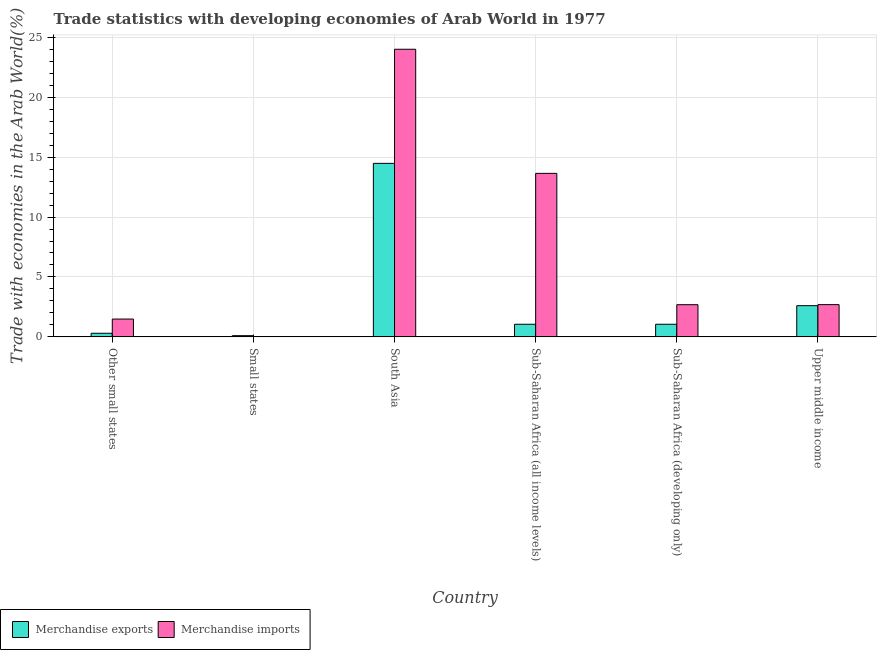How many different coloured bars are there?
Your answer should be compact. 2. Are the number of bars on each tick of the X-axis equal?
Provide a succinct answer. Yes. How many bars are there on the 1st tick from the left?
Your response must be concise. 2. How many bars are there on the 4th tick from the right?
Keep it short and to the point. 2. What is the label of the 1st group of bars from the left?
Keep it short and to the point. Other small states. In how many cases, is the number of bars for a given country not equal to the number of legend labels?
Make the answer very short. 0. What is the merchandise imports in Sub-Saharan Africa (all income levels)?
Offer a terse response. 13.64. Across all countries, what is the maximum merchandise imports?
Offer a terse response. 24. Across all countries, what is the minimum merchandise exports?
Provide a short and direct response. 0.1. In which country was the merchandise exports maximum?
Provide a succinct answer. South Asia. In which country was the merchandise exports minimum?
Offer a very short reply. Small states. What is the total merchandise imports in the graph?
Your answer should be compact. 44.54. What is the difference between the merchandise exports in Sub-Saharan Africa (developing only) and that in Upper middle income?
Offer a very short reply. -1.55. What is the difference between the merchandise imports in Sub-Saharan Africa (developing only) and the merchandise exports in South Asia?
Provide a short and direct response. -11.79. What is the average merchandise imports per country?
Offer a very short reply. 7.42. What is the difference between the merchandise imports and merchandise exports in Sub-Saharan Africa (all income levels)?
Your answer should be compact. 12.59. What is the ratio of the merchandise imports in South Asia to that in Sub-Saharan Africa (all income levels)?
Offer a very short reply. 1.76. Is the merchandise exports in Other small states less than that in Upper middle income?
Your response must be concise. Yes. What is the difference between the highest and the second highest merchandise exports?
Give a very brief answer. 11.88. What is the difference between the highest and the lowest merchandise exports?
Ensure brevity in your answer.  14.38. Is the sum of the merchandise exports in Small states and Sub-Saharan Africa (developing only) greater than the maximum merchandise imports across all countries?
Your answer should be compact. No. What does the 2nd bar from the left in South Asia represents?
Ensure brevity in your answer.  Merchandise imports. How many bars are there?
Offer a very short reply. 12. Are all the bars in the graph horizontal?
Your answer should be very brief. No. How many countries are there in the graph?
Your answer should be compact. 6. Does the graph contain grids?
Your answer should be very brief. Yes. Where does the legend appear in the graph?
Provide a succinct answer. Bottom left. How are the legend labels stacked?
Make the answer very short. Horizontal. What is the title of the graph?
Keep it short and to the point. Trade statistics with developing economies of Arab World in 1977. What is the label or title of the Y-axis?
Ensure brevity in your answer.  Trade with economies in the Arab World(%). What is the Trade with economies in the Arab World(%) in Merchandise exports in Other small states?
Your response must be concise. 0.3. What is the Trade with economies in the Arab World(%) in Merchandise imports in Other small states?
Your answer should be compact. 1.49. What is the Trade with economies in the Arab World(%) in Merchandise exports in Small states?
Offer a very short reply. 0.1. What is the Trade with economies in the Arab World(%) of Merchandise imports in Small states?
Provide a succinct answer. 0.03. What is the Trade with economies in the Arab World(%) of Merchandise exports in South Asia?
Offer a very short reply. 14.48. What is the Trade with economies in the Arab World(%) in Merchandise imports in South Asia?
Make the answer very short. 24. What is the Trade with economies in the Arab World(%) in Merchandise exports in Sub-Saharan Africa (all income levels)?
Provide a short and direct response. 1.05. What is the Trade with economies in the Arab World(%) of Merchandise imports in Sub-Saharan Africa (all income levels)?
Your answer should be very brief. 13.64. What is the Trade with economies in the Arab World(%) of Merchandise exports in Sub-Saharan Africa (developing only)?
Provide a short and direct response. 1.05. What is the Trade with economies in the Arab World(%) in Merchandise imports in Sub-Saharan Africa (developing only)?
Your answer should be very brief. 2.68. What is the Trade with economies in the Arab World(%) of Merchandise exports in Upper middle income?
Your answer should be compact. 2.6. What is the Trade with economies in the Arab World(%) of Merchandise imports in Upper middle income?
Your answer should be very brief. 2.69. Across all countries, what is the maximum Trade with economies in the Arab World(%) in Merchandise exports?
Offer a very short reply. 14.48. Across all countries, what is the maximum Trade with economies in the Arab World(%) of Merchandise imports?
Make the answer very short. 24. Across all countries, what is the minimum Trade with economies in the Arab World(%) in Merchandise exports?
Your response must be concise. 0.1. Across all countries, what is the minimum Trade with economies in the Arab World(%) of Merchandise imports?
Your response must be concise. 0.03. What is the total Trade with economies in the Arab World(%) of Merchandise exports in the graph?
Your answer should be very brief. 19.59. What is the total Trade with economies in the Arab World(%) in Merchandise imports in the graph?
Ensure brevity in your answer.  44.54. What is the difference between the Trade with economies in the Arab World(%) in Merchandise exports in Other small states and that in Small states?
Provide a succinct answer. 0.2. What is the difference between the Trade with economies in the Arab World(%) in Merchandise imports in Other small states and that in Small states?
Offer a terse response. 1.46. What is the difference between the Trade with economies in the Arab World(%) in Merchandise exports in Other small states and that in South Asia?
Offer a very short reply. -14.18. What is the difference between the Trade with economies in the Arab World(%) of Merchandise imports in Other small states and that in South Asia?
Offer a very short reply. -22.51. What is the difference between the Trade with economies in the Arab World(%) in Merchandise exports in Other small states and that in Sub-Saharan Africa (all income levels)?
Provide a short and direct response. -0.75. What is the difference between the Trade with economies in the Arab World(%) in Merchandise imports in Other small states and that in Sub-Saharan Africa (all income levels)?
Give a very brief answer. -12.16. What is the difference between the Trade with economies in the Arab World(%) in Merchandise exports in Other small states and that in Sub-Saharan Africa (developing only)?
Your response must be concise. -0.75. What is the difference between the Trade with economies in the Arab World(%) of Merchandise imports in Other small states and that in Sub-Saharan Africa (developing only)?
Your answer should be very brief. -1.2. What is the difference between the Trade with economies in the Arab World(%) of Merchandise exports in Other small states and that in Upper middle income?
Make the answer very short. -2.3. What is the difference between the Trade with economies in the Arab World(%) in Merchandise imports in Other small states and that in Upper middle income?
Offer a very short reply. -1.2. What is the difference between the Trade with economies in the Arab World(%) of Merchandise exports in Small states and that in South Asia?
Keep it short and to the point. -14.38. What is the difference between the Trade with economies in the Arab World(%) in Merchandise imports in Small states and that in South Asia?
Ensure brevity in your answer.  -23.97. What is the difference between the Trade with economies in the Arab World(%) in Merchandise exports in Small states and that in Sub-Saharan Africa (all income levels)?
Provide a short and direct response. -0.95. What is the difference between the Trade with economies in the Arab World(%) in Merchandise imports in Small states and that in Sub-Saharan Africa (all income levels)?
Make the answer very short. -13.61. What is the difference between the Trade with economies in the Arab World(%) in Merchandise exports in Small states and that in Sub-Saharan Africa (developing only)?
Offer a terse response. -0.95. What is the difference between the Trade with economies in the Arab World(%) of Merchandise imports in Small states and that in Sub-Saharan Africa (developing only)?
Offer a terse response. -2.65. What is the difference between the Trade with economies in the Arab World(%) of Merchandise exports in Small states and that in Upper middle income?
Your response must be concise. -2.5. What is the difference between the Trade with economies in the Arab World(%) in Merchandise imports in Small states and that in Upper middle income?
Provide a succinct answer. -2.66. What is the difference between the Trade with economies in the Arab World(%) of Merchandise exports in South Asia and that in Sub-Saharan Africa (all income levels)?
Your answer should be compact. 13.43. What is the difference between the Trade with economies in the Arab World(%) of Merchandise imports in South Asia and that in Sub-Saharan Africa (all income levels)?
Offer a very short reply. 10.36. What is the difference between the Trade with economies in the Arab World(%) in Merchandise exports in South Asia and that in Sub-Saharan Africa (developing only)?
Provide a short and direct response. 13.43. What is the difference between the Trade with economies in the Arab World(%) of Merchandise imports in South Asia and that in Sub-Saharan Africa (developing only)?
Offer a terse response. 21.32. What is the difference between the Trade with economies in the Arab World(%) of Merchandise exports in South Asia and that in Upper middle income?
Offer a terse response. 11.88. What is the difference between the Trade with economies in the Arab World(%) in Merchandise imports in South Asia and that in Upper middle income?
Give a very brief answer. 21.31. What is the difference between the Trade with economies in the Arab World(%) in Merchandise imports in Sub-Saharan Africa (all income levels) and that in Sub-Saharan Africa (developing only)?
Your response must be concise. 10.96. What is the difference between the Trade with economies in the Arab World(%) of Merchandise exports in Sub-Saharan Africa (all income levels) and that in Upper middle income?
Keep it short and to the point. -1.55. What is the difference between the Trade with economies in the Arab World(%) of Merchandise imports in Sub-Saharan Africa (all income levels) and that in Upper middle income?
Keep it short and to the point. 10.95. What is the difference between the Trade with economies in the Arab World(%) in Merchandise exports in Sub-Saharan Africa (developing only) and that in Upper middle income?
Offer a very short reply. -1.55. What is the difference between the Trade with economies in the Arab World(%) in Merchandise imports in Sub-Saharan Africa (developing only) and that in Upper middle income?
Provide a short and direct response. -0.01. What is the difference between the Trade with economies in the Arab World(%) in Merchandise exports in Other small states and the Trade with economies in the Arab World(%) in Merchandise imports in Small states?
Provide a succinct answer. 0.27. What is the difference between the Trade with economies in the Arab World(%) in Merchandise exports in Other small states and the Trade with economies in the Arab World(%) in Merchandise imports in South Asia?
Your response must be concise. -23.7. What is the difference between the Trade with economies in the Arab World(%) in Merchandise exports in Other small states and the Trade with economies in the Arab World(%) in Merchandise imports in Sub-Saharan Africa (all income levels)?
Provide a succinct answer. -13.34. What is the difference between the Trade with economies in the Arab World(%) in Merchandise exports in Other small states and the Trade with economies in the Arab World(%) in Merchandise imports in Sub-Saharan Africa (developing only)?
Your response must be concise. -2.38. What is the difference between the Trade with economies in the Arab World(%) of Merchandise exports in Other small states and the Trade with economies in the Arab World(%) of Merchandise imports in Upper middle income?
Keep it short and to the point. -2.39. What is the difference between the Trade with economies in the Arab World(%) in Merchandise exports in Small states and the Trade with economies in the Arab World(%) in Merchandise imports in South Asia?
Your response must be concise. -23.9. What is the difference between the Trade with economies in the Arab World(%) in Merchandise exports in Small states and the Trade with economies in the Arab World(%) in Merchandise imports in Sub-Saharan Africa (all income levels)?
Offer a very short reply. -13.54. What is the difference between the Trade with economies in the Arab World(%) of Merchandise exports in Small states and the Trade with economies in the Arab World(%) of Merchandise imports in Sub-Saharan Africa (developing only)?
Your answer should be very brief. -2.58. What is the difference between the Trade with economies in the Arab World(%) of Merchandise exports in Small states and the Trade with economies in the Arab World(%) of Merchandise imports in Upper middle income?
Make the answer very short. -2.59. What is the difference between the Trade with economies in the Arab World(%) in Merchandise exports in South Asia and the Trade with economies in the Arab World(%) in Merchandise imports in Sub-Saharan Africa (all income levels)?
Keep it short and to the point. 0.84. What is the difference between the Trade with economies in the Arab World(%) in Merchandise exports in South Asia and the Trade with economies in the Arab World(%) in Merchandise imports in Sub-Saharan Africa (developing only)?
Give a very brief answer. 11.79. What is the difference between the Trade with economies in the Arab World(%) of Merchandise exports in South Asia and the Trade with economies in the Arab World(%) of Merchandise imports in Upper middle income?
Your answer should be compact. 11.79. What is the difference between the Trade with economies in the Arab World(%) in Merchandise exports in Sub-Saharan Africa (all income levels) and the Trade with economies in the Arab World(%) in Merchandise imports in Sub-Saharan Africa (developing only)?
Your response must be concise. -1.63. What is the difference between the Trade with economies in the Arab World(%) of Merchandise exports in Sub-Saharan Africa (all income levels) and the Trade with economies in the Arab World(%) of Merchandise imports in Upper middle income?
Give a very brief answer. -1.64. What is the difference between the Trade with economies in the Arab World(%) in Merchandise exports in Sub-Saharan Africa (developing only) and the Trade with economies in the Arab World(%) in Merchandise imports in Upper middle income?
Give a very brief answer. -1.64. What is the average Trade with economies in the Arab World(%) of Merchandise exports per country?
Your response must be concise. 3.26. What is the average Trade with economies in the Arab World(%) in Merchandise imports per country?
Make the answer very short. 7.42. What is the difference between the Trade with economies in the Arab World(%) of Merchandise exports and Trade with economies in the Arab World(%) of Merchandise imports in Other small states?
Your answer should be compact. -1.18. What is the difference between the Trade with economies in the Arab World(%) in Merchandise exports and Trade with economies in the Arab World(%) in Merchandise imports in Small states?
Offer a very short reply. 0.07. What is the difference between the Trade with economies in the Arab World(%) in Merchandise exports and Trade with economies in the Arab World(%) in Merchandise imports in South Asia?
Your answer should be compact. -9.52. What is the difference between the Trade with economies in the Arab World(%) in Merchandise exports and Trade with economies in the Arab World(%) in Merchandise imports in Sub-Saharan Africa (all income levels)?
Ensure brevity in your answer.  -12.59. What is the difference between the Trade with economies in the Arab World(%) of Merchandise exports and Trade with economies in the Arab World(%) of Merchandise imports in Sub-Saharan Africa (developing only)?
Give a very brief answer. -1.63. What is the difference between the Trade with economies in the Arab World(%) of Merchandise exports and Trade with economies in the Arab World(%) of Merchandise imports in Upper middle income?
Offer a terse response. -0.09. What is the ratio of the Trade with economies in the Arab World(%) in Merchandise exports in Other small states to that in Small states?
Offer a terse response. 2.99. What is the ratio of the Trade with economies in the Arab World(%) of Merchandise imports in Other small states to that in Small states?
Offer a terse response. 48.01. What is the ratio of the Trade with economies in the Arab World(%) in Merchandise exports in Other small states to that in South Asia?
Your answer should be very brief. 0.02. What is the ratio of the Trade with economies in the Arab World(%) in Merchandise imports in Other small states to that in South Asia?
Your answer should be very brief. 0.06. What is the ratio of the Trade with economies in the Arab World(%) in Merchandise exports in Other small states to that in Sub-Saharan Africa (all income levels)?
Make the answer very short. 0.29. What is the ratio of the Trade with economies in the Arab World(%) of Merchandise imports in Other small states to that in Sub-Saharan Africa (all income levels)?
Provide a short and direct response. 0.11. What is the ratio of the Trade with economies in the Arab World(%) of Merchandise exports in Other small states to that in Sub-Saharan Africa (developing only)?
Provide a short and direct response. 0.29. What is the ratio of the Trade with economies in the Arab World(%) in Merchandise imports in Other small states to that in Sub-Saharan Africa (developing only)?
Provide a short and direct response. 0.55. What is the ratio of the Trade with economies in the Arab World(%) of Merchandise exports in Other small states to that in Upper middle income?
Keep it short and to the point. 0.12. What is the ratio of the Trade with economies in the Arab World(%) of Merchandise imports in Other small states to that in Upper middle income?
Your answer should be very brief. 0.55. What is the ratio of the Trade with economies in the Arab World(%) of Merchandise exports in Small states to that in South Asia?
Your response must be concise. 0.01. What is the ratio of the Trade with economies in the Arab World(%) of Merchandise imports in Small states to that in South Asia?
Offer a terse response. 0. What is the ratio of the Trade with economies in the Arab World(%) of Merchandise exports in Small states to that in Sub-Saharan Africa (all income levels)?
Make the answer very short. 0.1. What is the ratio of the Trade with economies in the Arab World(%) of Merchandise imports in Small states to that in Sub-Saharan Africa (all income levels)?
Offer a terse response. 0. What is the ratio of the Trade with economies in the Arab World(%) in Merchandise exports in Small states to that in Sub-Saharan Africa (developing only)?
Provide a succinct answer. 0.1. What is the ratio of the Trade with economies in the Arab World(%) of Merchandise imports in Small states to that in Sub-Saharan Africa (developing only)?
Offer a very short reply. 0.01. What is the ratio of the Trade with economies in the Arab World(%) of Merchandise exports in Small states to that in Upper middle income?
Your answer should be very brief. 0.04. What is the ratio of the Trade with economies in the Arab World(%) in Merchandise imports in Small states to that in Upper middle income?
Give a very brief answer. 0.01. What is the ratio of the Trade with economies in the Arab World(%) of Merchandise exports in South Asia to that in Sub-Saharan Africa (all income levels)?
Keep it short and to the point. 13.76. What is the ratio of the Trade with economies in the Arab World(%) of Merchandise imports in South Asia to that in Sub-Saharan Africa (all income levels)?
Give a very brief answer. 1.76. What is the ratio of the Trade with economies in the Arab World(%) of Merchandise exports in South Asia to that in Sub-Saharan Africa (developing only)?
Your answer should be very brief. 13.76. What is the ratio of the Trade with economies in the Arab World(%) of Merchandise imports in South Asia to that in Sub-Saharan Africa (developing only)?
Provide a short and direct response. 8.94. What is the ratio of the Trade with economies in the Arab World(%) of Merchandise exports in South Asia to that in Upper middle income?
Make the answer very short. 5.56. What is the ratio of the Trade with economies in the Arab World(%) in Merchandise imports in South Asia to that in Upper middle income?
Provide a short and direct response. 8.92. What is the ratio of the Trade with economies in the Arab World(%) of Merchandise imports in Sub-Saharan Africa (all income levels) to that in Sub-Saharan Africa (developing only)?
Make the answer very short. 5.08. What is the ratio of the Trade with economies in the Arab World(%) in Merchandise exports in Sub-Saharan Africa (all income levels) to that in Upper middle income?
Offer a very short reply. 0.4. What is the ratio of the Trade with economies in the Arab World(%) of Merchandise imports in Sub-Saharan Africa (all income levels) to that in Upper middle income?
Ensure brevity in your answer.  5.07. What is the ratio of the Trade with economies in the Arab World(%) in Merchandise exports in Sub-Saharan Africa (developing only) to that in Upper middle income?
Provide a succinct answer. 0.4. What is the difference between the highest and the second highest Trade with economies in the Arab World(%) in Merchandise exports?
Provide a succinct answer. 11.88. What is the difference between the highest and the second highest Trade with economies in the Arab World(%) of Merchandise imports?
Your response must be concise. 10.36. What is the difference between the highest and the lowest Trade with economies in the Arab World(%) in Merchandise exports?
Keep it short and to the point. 14.38. What is the difference between the highest and the lowest Trade with economies in the Arab World(%) in Merchandise imports?
Make the answer very short. 23.97. 